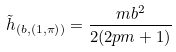<formula> <loc_0><loc_0><loc_500><loc_500>\tilde { h } _ { ( b , \left ( 1 , \pi \right ) ) } = \frac { m b ^ { 2 } } { 2 ( 2 p m + 1 ) } \,</formula> 